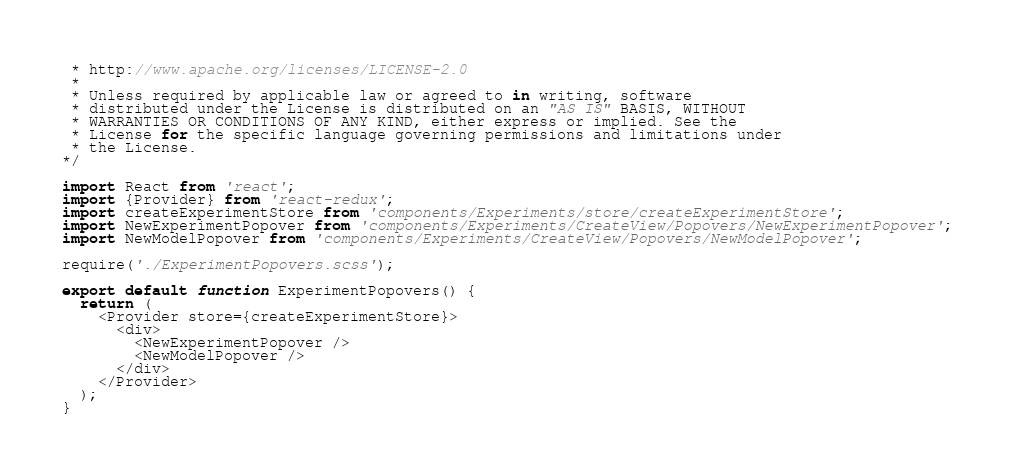Convert code to text. <code><loc_0><loc_0><loc_500><loc_500><_JavaScript_> * http://www.apache.org/licenses/LICENSE-2.0
 *
 * Unless required by applicable law or agreed to in writing, software
 * distributed under the License is distributed on an "AS IS" BASIS, WITHOUT
 * WARRANTIES OR CONDITIONS OF ANY KIND, either express or implied. See the
 * License for the specific language governing permissions and limitations under
 * the License.
*/

import React from 'react';
import {Provider} from 'react-redux';
import createExperimentStore from 'components/Experiments/store/createExperimentStore';
import NewExperimentPopover from 'components/Experiments/CreateView/Popovers/NewExperimentPopover';
import NewModelPopover from 'components/Experiments/CreateView/Popovers/NewModelPopover';

require('./ExperimentPopovers.scss');

export default function ExperimentPopovers() {
  return (
    <Provider store={createExperimentStore}>
      <div>
        <NewExperimentPopover />
        <NewModelPopover />
      </div>
    </Provider>
  );
}
</code> 